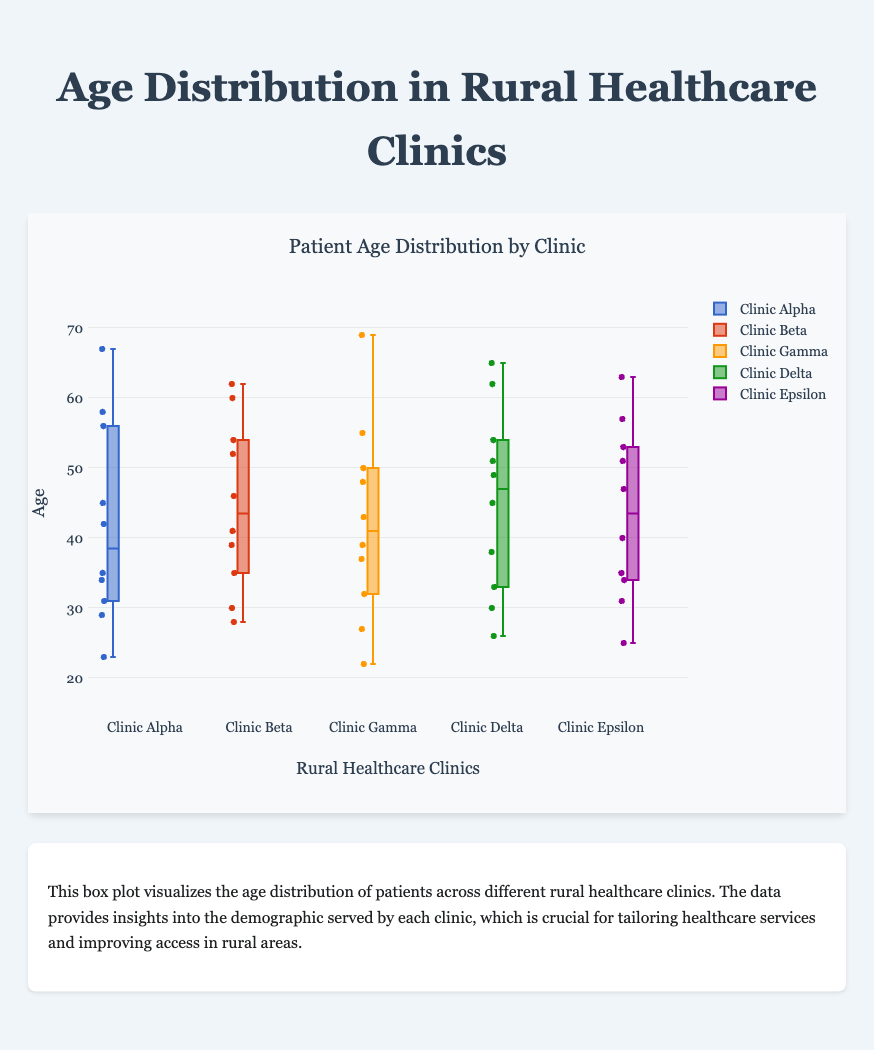What is the title of the plot? The title of the plot is typically located at the top and summarizes the main subject of the figure. In this case, it should directly describe what the plot shows.
Answer: Patient Age Distribution by Clinic Which clinic has the widest age range? To find the clinic with the widest age range, look at the length of the boxes and whiskers for each clinic. The wider the box and whiskers combined, the wider the age range. Clinic Alpha has the widest age range due to its longer whiskers.
Answer: Clinic Alpha What is the median age at Clinic Gamma? The median is represented by the line inside the box of each box plot. The median line for Clinic Gamma is at age 39.
Answer: 39 Which clinic has the oldest patient? The oldest patient's age can be identified by the highest data point or the top whisker in each box plot. Clinic Alpha has the oldest patient with an age of 67.
Answer: Clinic Alpha How do the median ages of Clinic Beta and Clinic Delta compare? Comparing the median lines in the boxes for Clinic Beta and Clinic Delta shows that both medians align at age 46.
Answer: They are equal What is the interquartile range (IQR) of ages for Clinic Epsilon? The interquartile range is the difference between the third quartile (top of the box) and the first quartile (bottom of the box). For Clinic Epsilon, the IQR is (51 - 34) = 17.
Answer: 17 Which clinic has the most variability in patient ages? Variability in a box plot can be judged by the length of the box and whiskers. The greater the total length, the more variability. Clinic Alpha has the most variability.
Answer: Clinic Alpha What is the youngest age recorded at Clinic Delta? The youngest age is represented by the lowest data point or whisker in the box plot. In Clinic Delta, the youngest age is 26.
Answer: 26 How does the third quartile age of Clinic Beta compare to that of Clinic Gamma? Look at the top of the boxes for Clinic Beta and Gamma. Clinic Beta’s third quartile age is slightly higher at age 54 compared to Clinic Gamma at age 50.
Answer: Clinic Beta is higher Which clinic has the most concentrated age distribution? A concentrated distribution implies a shorter box and whiskers. Hence, the box plot with the smallest overall span should be identified. Clinic Gamma appears to have the most concentrated age distribution.
Answer: Clinic Gamma 